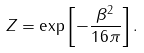Convert formula to latex. <formula><loc_0><loc_0><loc_500><loc_500>Z = \exp \left [ - \frac { \beta ^ { 2 } } { 1 6 \pi } \right ] .</formula> 